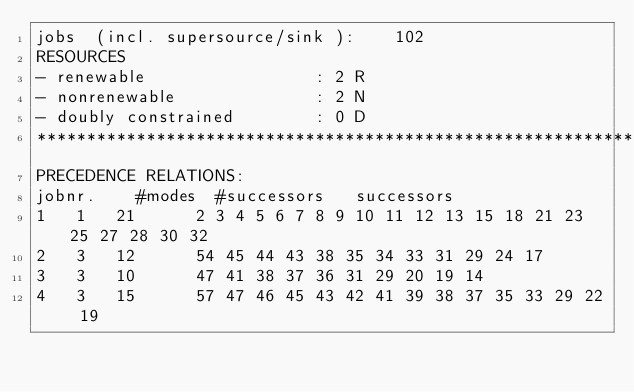<code> <loc_0><loc_0><loc_500><loc_500><_ObjectiveC_>jobs  (incl. supersource/sink ):	102
RESOURCES
- renewable                 : 2 R
- nonrenewable              : 2 N
- doubly constrained        : 0 D
************************************************************************
PRECEDENCE RELATIONS:
jobnr.    #modes  #successors   successors
1	1	21		2 3 4 5 6 7 8 9 10 11 12 13 15 18 21 23 25 27 28 30 32 
2	3	12		54 45 44 43 38 35 34 33 31 29 24 17 
3	3	10		47 41 38 37 36 31 29 20 19 14 
4	3	15		57 47 46 45 43 42 41 39 38 37 35 33 29 22 19 </code> 